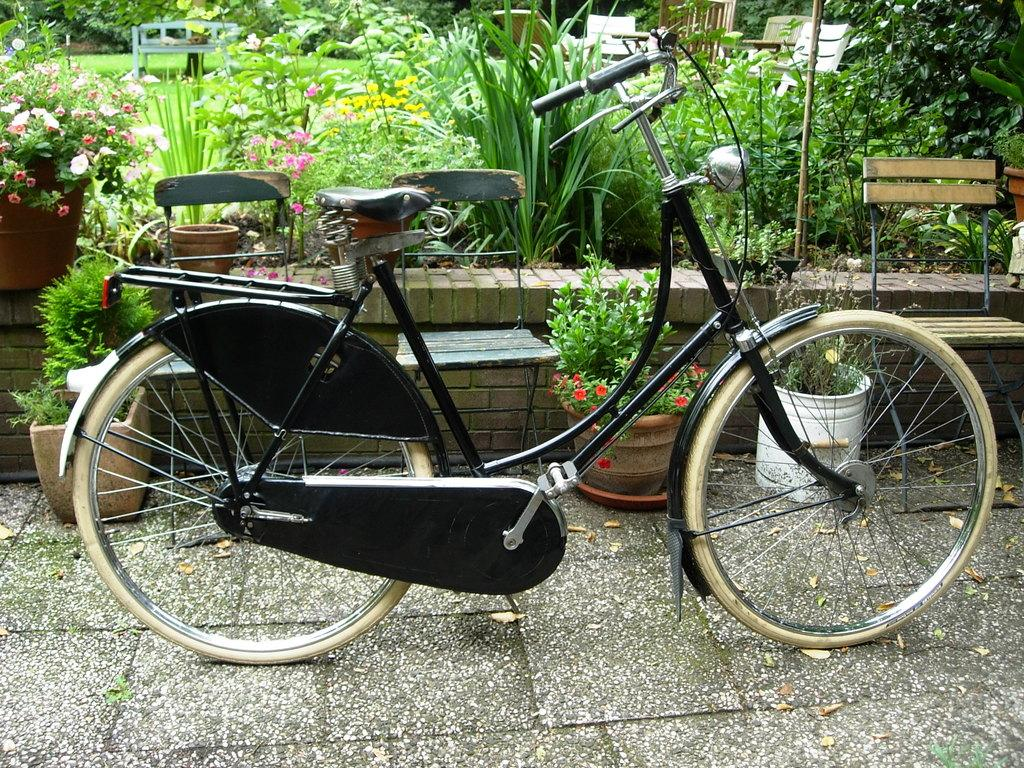What type of bicycle can be seen in the image? There is a black bicycle in the image. What is located behind the bicycle? There are many plants behind the bicycle. What type of seating is present in the image? Chairs are present in the image. What type of vegetation is present behind the plants? There is grass behind the plants. What type of outdoor furniture is present on the grass? A bench is present on the grass. What type of tin can be seen in the image? There is no tin present in the image. What type of discovery is being made in the image? There is no discovery being made in the image; it is a scene featuring a bicycle, plants, chairs, grass, and a bench. 